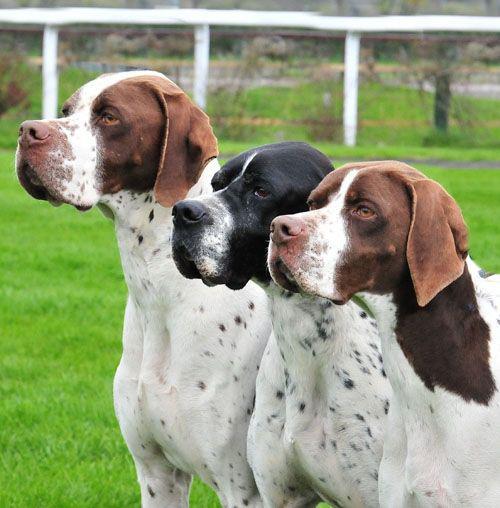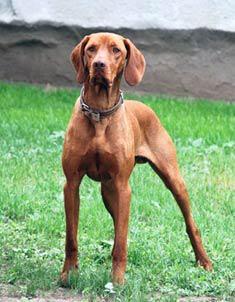The first image is the image on the left, the second image is the image on the right. Analyze the images presented: Is the assertion "The left image shows a row of three dogs with upright heads, and the right image shows one upright dog wearing a collar." valid? Answer yes or no. Yes. The first image is the image on the left, the second image is the image on the right. Evaluate the accuracy of this statement regarding the images: "In the image on the left there are 3 dogs.". Is it true? Answer yes or no. Yes. 